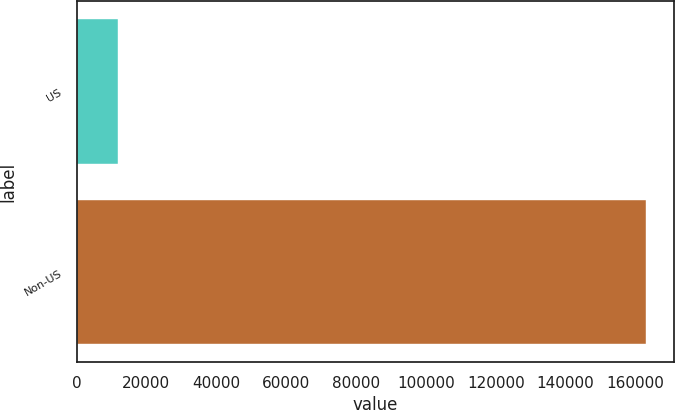<chart> <loc_0><loc_0><loc_500><loc_500><bar_chart><fcel>US<fcel>Non-US<nl><fcel>11730<fcel>163019<nl></chart> 